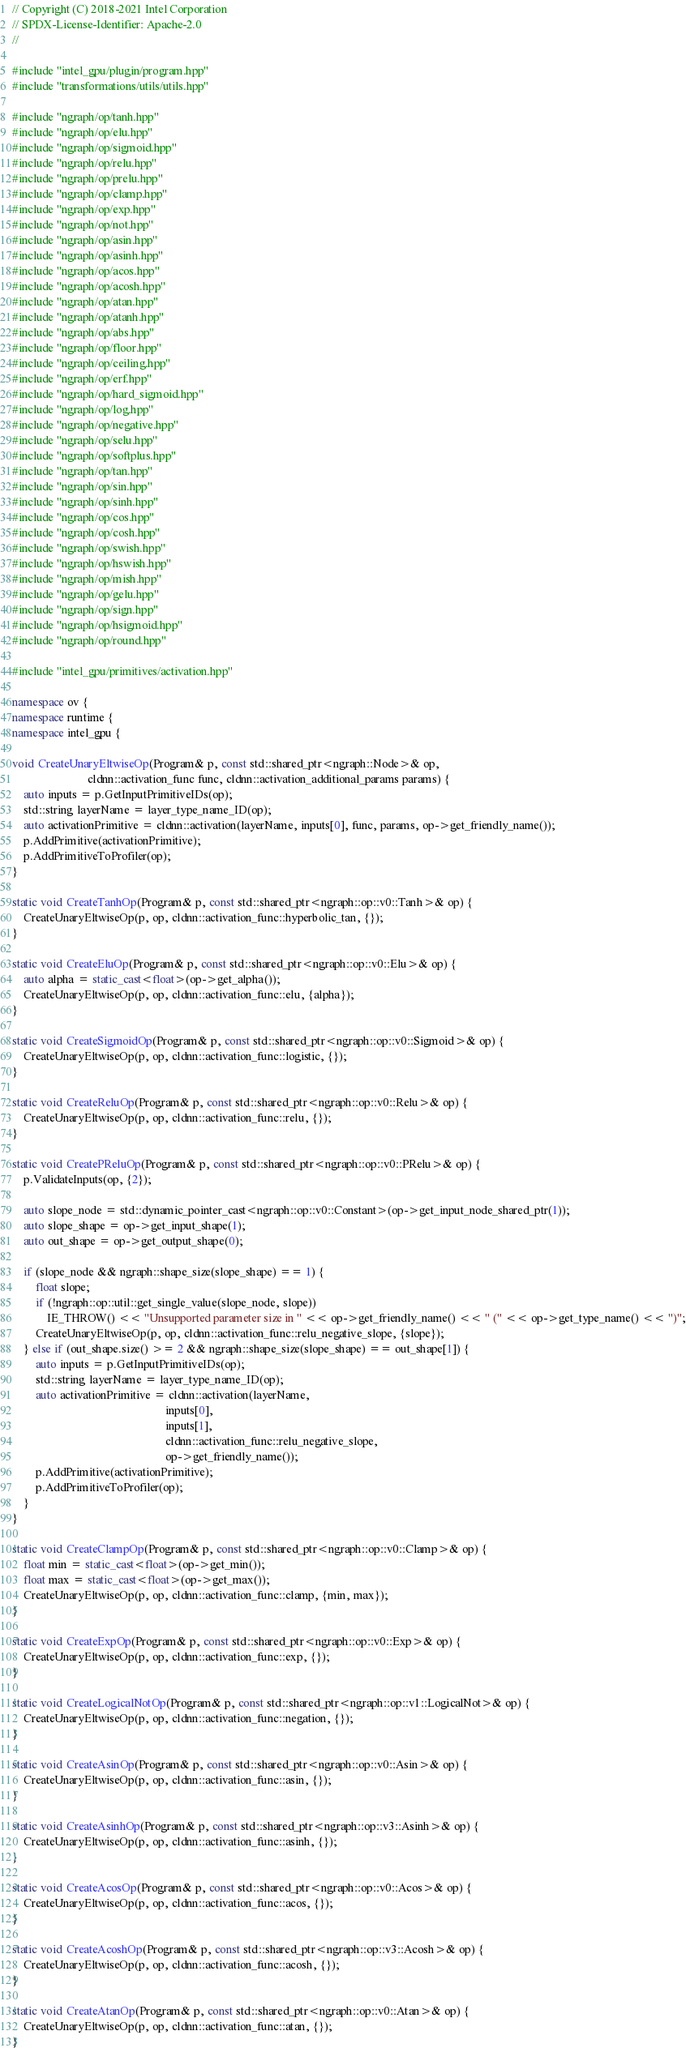<code> <loc_0><loc_0><loc_500><loc_500><_C++_>// Copyright (C) 2018-2021 Intel Corporation
// SPDX-License-Identifier: Apache-2.0
//

#include "intel_gpu/plugin/program.hpp"
#include "transformations/utils/utils.hpp"

#include "ngraph/op/tanh.hpp"
#include "ngraph/op/elu.hpp"
#include "ngraph/op/sigmoid.hpp"
#include "ngraph/op/relu.hpp"
#include "ngraph/op/prelu.hpp"
#include "ngraph/op/clamp.hpp"
#include "ngraph/op/exp.hpp"
#include "ngraph/op/not.hpp"
#include "ngraph/op/asin.hpp"
#include "ngraph/op/asinh.hpp"
#include "ngraph/op/acos.hpp"
#include "ngraph/op/acosh.hpp"
#include "ngraph/op/atan.hpp"
#include "ngraph/op/atanh.hpp"
#include "ngraph/op/abs.hpp"
#include "ngraph/op/floor.hpp"
#include "ngraph/op/ceiling.hpp"
#include "ngraph/op/erf.hpp"
#include "ngraph/op/hard_sigmoid.hpp"
#include "ngraph/op/log.hpp"
#include "ngraph/op/negative.hpp"
#include "ngraph/op/selu.hpp"
#include "ngraph/op/softplus.hpp"
#include "ngraph/op/tan.hpp"
#include "ngraph/op/sin.hpp"
#include "ngraph/op/sinh.hpp"
#include "ngraph/op/cos.hpp"
#include "ngraph/op/cosh.hpp"
#include "ngraph/op/swish.hpp"
#include "ngraph/op/hswish.hpp"
#include "ngraph/op/mish.hpp"
#include "ngraph/op/gelu.hpp"
#include "ngraph/op/sign.hpp"
#include "ngraph/op/hsigmoid.hpp"
#include "ngraph/op/round.hpp"

#include "intel_gpu/primitives/activation.hpp"

namespace ov {
namespace runtime {
namespace intel_gpu {

void CreateUnaryEltwiseOp(Program& p, const std::shared_ptr<ngraph::Node>& op,
                          cldnn::activation_func func, cldnn::activation_additional_params params) {
    auto inputs = p.GetInputPrimitiveIDs(op);
    std::string layerName = layer_type_name_ID(op);
    auto activationPrimitive = cldnn::activation(layerName, inputs[0], func, params, op->get_friendly_name());
    p.AddPrimitive(activationPrimitive);
    p.AddPrimitiveToProfiler(op);
}

static void CreateTanhOp(Program& p, const std::shared_ptr<ngraph::op::v0::Tanh>& op) {
    CreateUnaryEltwiseOp(p, op, cldnn::activation_func::hyperbolic_tan, {});
}

static void CreateEluOp(Program& p, const std::shared_ptr<ngraph::op::v0::Elu>& op) {
    auto alpha = static_cast<float>(op->get_alpha());
    CreateUnaryEltwiseOp(p, op, cldnn::activation_func::elu, {alpha});
}

static void CreateSigmoidOp(Program& p, const std::shared_ptr<ngraph::op::v0::Sigmoid>& op) {
    CreateUnaryEltwiseOp(p, op, cldnn::activation_func::logistic, {});
}

static void CreateReluOp(Program& p, const std::shared_ptr<ngraph::op::v0::Relu>& op) {
    CreateUnaryEltwiseOp(p, op, cldnn::activation_func::relu, {});
}

static void CreatePReluOp(Program& p, const std::shared_ptr<ngraph::op::v0::PRelu>& op) {
    p.ValidateInputs(op, {2});

    auto slope_node = std::dynamic_pointer_cast<ngraph::op::v0::Constant>(op->get_input_node_shared_ptr(1));
    auto slope_shape = op->get_input_shape(1);
    auto out_shape = op->get_output_shape(0);

    if (slope_node && ngraph::shape_size(slope_shape) == 1) {
        float slope;
        if (!ngraph::op::util::get_single_value(slope_node, slope))
            IE_THROW() << "Unsupported parameter size in " << op->get_friendly_name() << " (" << op->get_type_name() << ")";
        CreateUnaryEltwiseOp(p, op, cldnn::activation_func::relu_negative_slope, {slope});
    } else if (out_shape.size() >= 2 && ngraph::shape_size(slope_shape) == out_shape[1]) {
        auto inputs = p.GetInputPrimitiveIDs(op);
        std::string layerName = layer_type_name_ID(op);
        auto activationPrimitive = cldnn::activation(layerName,
                                                     inputs[0],
                                                     inputs[1],
                                                     cldnn::activation_func::relu_negative_slope,
                                                     op->get_friendly_name());
        p.AddPrimitive(activationPrimitive);
        p.AddPrimitiveToProfiler(op);
    }
}

static void CreateClampOp(Program& p, const std::shared_ptr<ngraph::op::v0::Clamp>& op) {
    float min = static_cast<float>(op->get_min());
    float max = static_cast<float>(op->get_max());
    CreateUnaryEltwiseOp(p, op, cldnn::activation_func::clamp, {min, max});
}

static void CreateExpOp(Program& p, const std::shared_ptr<ngraph::op::v0::Exp>& op) {
    CreateUnaryEltwiseOp(p, op, cldnn::activation_func::exp, {});
}

static void CreateLogicalNotOp(Program& p, const std::shared_ptr<ngraph::op::v1::LogicalNot>& op) {
    CreateUnaryEltwiseOp(p, op, cldnn::activation_func::negation, {});
}

static void CreateAsinOp(Program& p, const std::shared_ptr<ngraph::op::v0::Asin>& op) {
    CreateUnaryEltwiseOp(p, op, cldnn::activation_func::asin, {});
}

static void CreateAsinhOp(Program& p, const std::shared_ptr<ngraph::op::v3::Asinh>& op) {
    CreateUnaryEltwiseOp(p, op, cldnn::activation_func::asinh, {});
}

static void CreateAcosOp(Program& p, const std::shared_ptr<ngraph::op::v0::Acos>& op) {
    CreateUnaryEltwiseOp(p, op, cldnn::activation_func::acos, {});
}

static void CreateAcoshOp(Program& p, const std::shared_ptr<ngraph::op::v3::Acosh>& op) {
    CreateUnaryEltwiseOp(p, op, cldnn::activation_func::acosh, {});
}

static void CreateAtanOp(Program& p, const std::shared_ptr<ngraph::op::v0::Atan>& op) {
    CreateUnaryEltwiseOp(p, op, cldnn::activation_func::atan, {});
}
</code> 